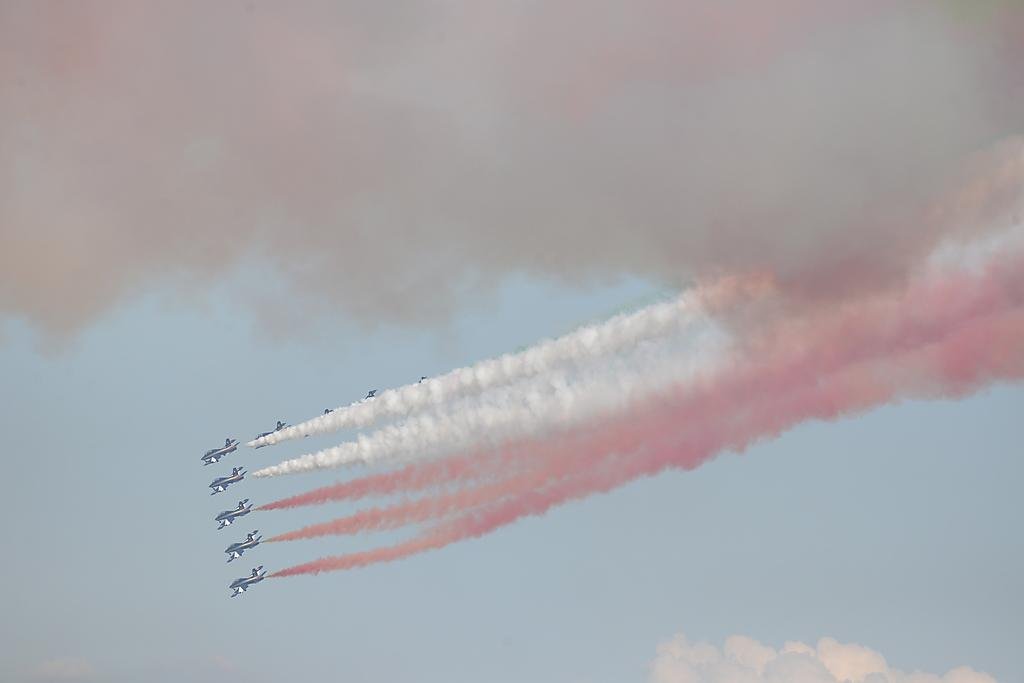What is the main subject of the image? The main subject of the image is jets. What is happening to the jets in the image? The jets are producing smoke. Where is the smoke visible in the image? The smoke is visible in the sky. How would you describe the sky in the image? The sky appears cloudy in the image. What type of fruit can be seen hanging from the jets in the image? There is no fruit hanging from the jets in the image; the jets are producing smoke. How many stamps are visible on the smoke in the image? There are no stamps present in the image; the jets are producing smoke without any stamps. 